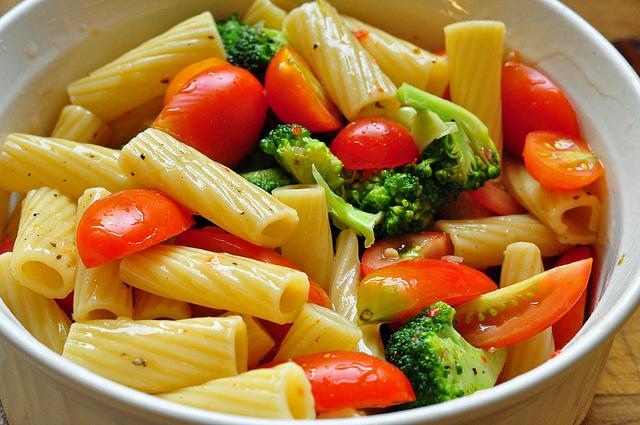How many  varieties of vegetables are in the pasta?
Keep it brief. 2. What type of noodles are these?
Concise answer only. Ziti. Are there tomatoes in the pasta?
Quick response, please. Yes. 